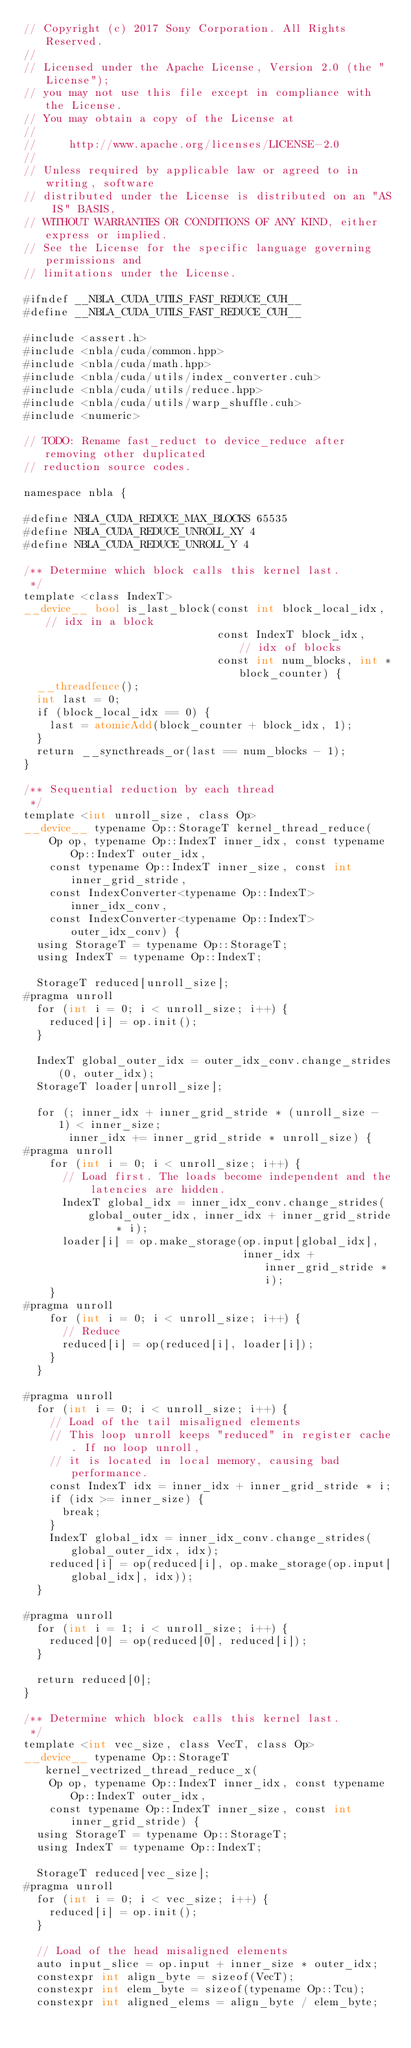Convert code to text. <code><loc_0><loc_0><loc_500><loc_500><_Cuda_>// Copyright (c) 2017 Sony Corporation. All Rights Reserved.
//
// Licensed under the Apache License, Version 2.0 (the "License");
// you may not use this file except in compliance with the License.
// You may obtain a copy of the License at
//
//     http://www.apache.org/licenses/LICENSE-2.0
//
// Unless required by applicable law or agreed to in writing, software
// distributed under the License is distributed on an "AS IS" BASIS,
// WITHOUT WARRANTIES OR CONDITIONS OF ANY KIND, either express or implied.
// See the License for the specific language governing permissions and
// limitations under the License.

#ifndef __NBLA_CUDA_UTILS_FAST_REDUCE_CUH__
#define __NBLA_CUDA_UTILS_FAST_REDUCE_CUH__

#include <assert.h>
#include <nbla/cuda/common.hpp>
#include <nbla/cuda/math.hpp>
#include <nbla/cuda/utils/index_converter.cuh>
#include <nbla/cuda/utils/reduce.hpp>
#include <nbla/cuda/utils/warp_shuffle.cuh>
#include <numeric>

// TODO: Rename fast_reduct to device_reduce after removing other duplicated
// reduction source codes.

namespace nbla {

#define NBLA_CUDA_REDUCE_MAX_BLOCKS 65535
#define NBLA_CUDA_REDUCE_UNROLL_XY 4
#define NBLA_CUDA_REDUCE_UNROLL_Y 4

/** Determine which block calls this kernel last.
 */
template <class IndexT>
__device__ bool is_last_block(const int block_local_idx, // idx in a block
                              const IndexT block_idx,    // idx of blocks
                              const int num_blocks, int *block_counter) {
  __threadfence();
  int last = 0;
  if (block_local_idx == 0) {
    last = atomicAdd(block_counter + block_idx, 1);
  }
  return __syncthreads_or(last == num_blocks - 1);
}

/** Sequential reduction by each thread
 */
template <int unroll_size, class Op>
__device__ typename Op::StorageT kernel_thread_reduce(
    Op op, typename Op::IndexT inner_idx, const typename Op::IndexT outer_idx,
    const typename Op::IndexT inner_size, const int inner_grid_stride,
    const IndexConverter<typename Op::IndexT> inner_idx_conv,
    const IndexConverter<typename Op::IndexT> outer_idx_conv) {
  using StorageT = typename Op::StorageT;
  using IndexT = typename Op::IndexT;

  StorageT reduced[unroll_size];
#pragma unroll
  for (int i = 0; i < unroll_size; i++) {
    reduced[i] = op.init();
  }

  IndexT global_outer_idx = outer_idx_conv.change_strides(0, outer_idx);
  StorageT loader[unroll_size];

  for (; inner_idx + inner_grid_stride * (unroll_size - 1) < inner_size;
       inner_idx += inner_grid_stride * unroll_size) {
#pragma unroll
    for (int i = 0; i < unroll_size; i++) {
      // Load first. The loads become independent and the latencies are hidden.
      IndexT global_idx = inner_idx_conv.change_strides(
          global_outer_idx, inner_idx + inner_grid_stride * i);
      loader[i] = op.make_storage(op.input[global_idx],
                                  inner_idx + inner_grid_stride * i);
    }
#pragma unroll
    for (int i = 0; i < unroll_size; i++) {
      // Reduce
      reduced[i] = op(reduced[i], loader[i]);
    }
  }

#pragma unroll
  for (int i = 0; i < unroll_size; i++) {
    // Load of the tail misaligned elements
    // This loop unroll keeps "reduced" in register cache. If no loop unroll,
    // it is located in local memory, causing bad performance.
    const IndexT idx = inner_idx + inner_grid_stride * i;
    if (idx >= inner_size) {
      break;
    }
    IndexT global_idx = inner_idx_conv.change_strides(global_outer_idx, idx);
    reduced[i] = op(reduced[i], op.make_storage(op.input[global_idx], idx));
  }

#pragma unroll
  for (int i = 1; i < unroll_size; i++) {
    reduced[0] = op(reduced[0], reduced[i]);
  }

  return reduced[0];
}

/** Determine which block calls this kernel last.
 */
template <int vec_size, class VecT, class Op>
__device__ typename Op::StorageT kernel_vectrized_thread_reduce_x(
    Op op, typename Op::IndexT inner_idx, const typename Op::IndexT outer_idx,
    const typename Op::IndexT inner_size, const int inner_grid_stride) {
  using StorageT = typename Op::StorageT;
  using IndexT = typename Op::IndexT;

  StorageT reduced[vec_size];
#pragma unroll
  for (int i = 0; i < vec_size; i++) {
    reduced[i] = op.init();
  }

  // Load of the head misaligned elements
  auto input_slice = op.input + inner_size * outer_idx;
  constexpr int align_byte = sizeof(VecT);
  constexpr int elem_byte = sizeof(typename Op::Tcu);
  constexpr int aligned_elems = align_byte / elem_byte;</code> 